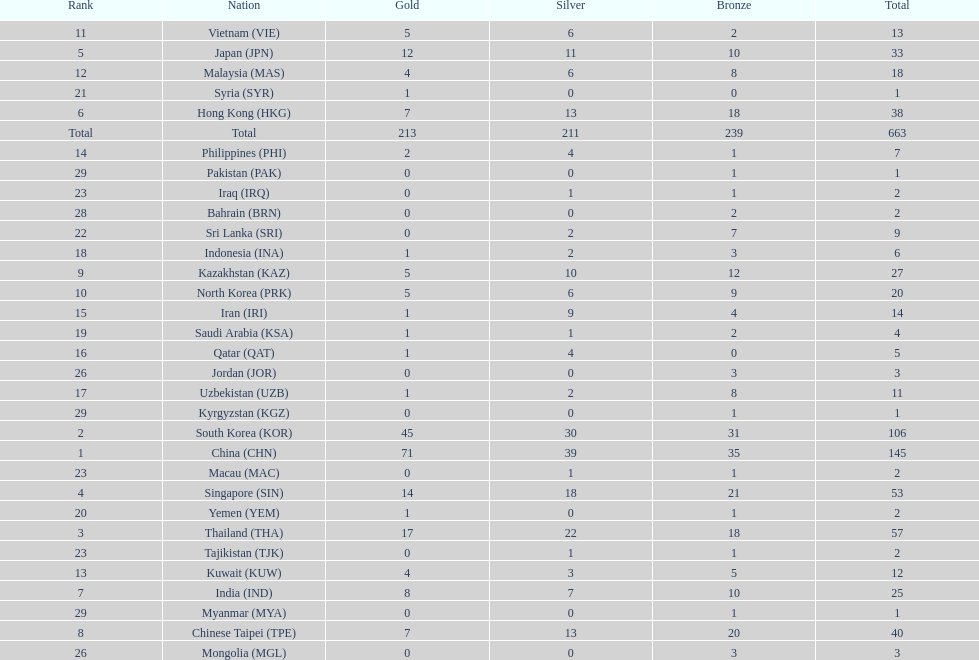What were the number of medals iran earned? 14. 